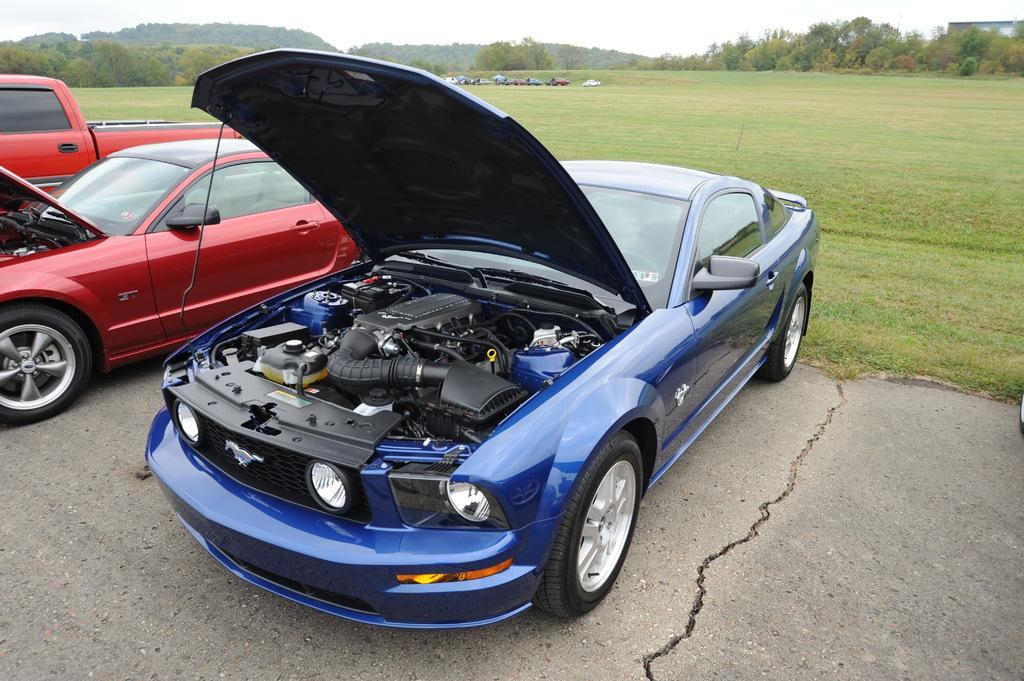What can be seen in the image? There are vehicles in the image. What colors are the vehicles? The vehicles are in blue and red colors. What is visible in the background of the image? There are trees and the sky in the background of the image. What color are the trees? The trees are in green color. What color is the sky? The sky is in white color. Can you see a farmer working in the field in the image? There is no farmer or field present in the image. How many stars can be seen in the sky in the image? The sky is in white color, and there are no stars visible in the image. 